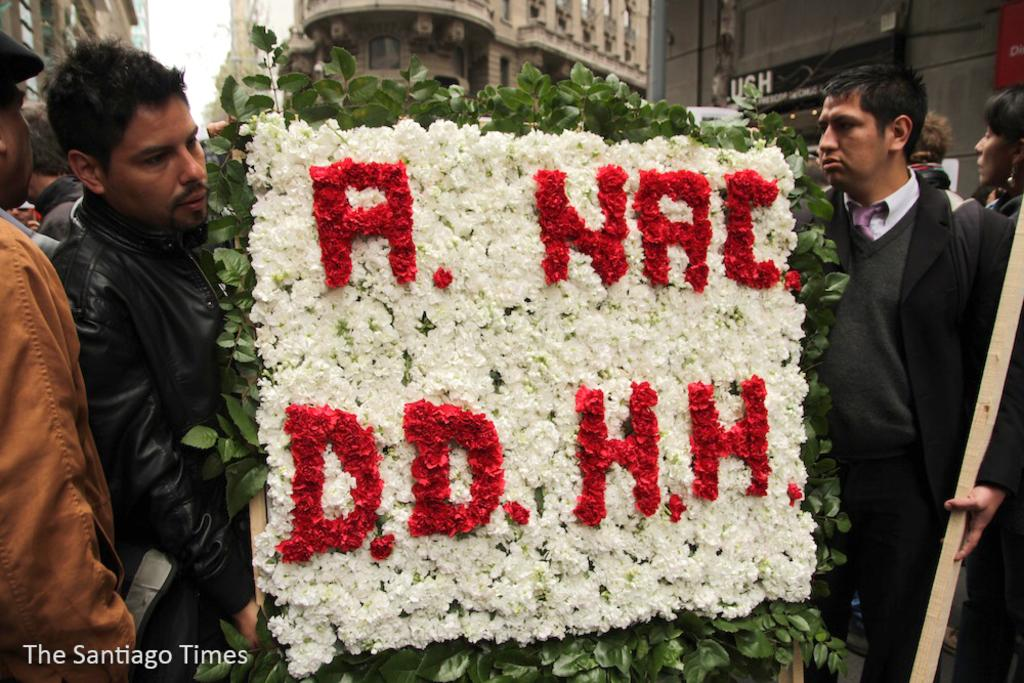What are the men in the image holding? The men in the image are holding a bird. How is the bird decorated? The bird is decorated with flowers and leaves. What can be seen in the background of the image? There are buildings and the sky visible in the background of the image. What type of produce is being sold by the boys in the image? There are no boys or produce present in the image; it features men holding a bird. What is the opinion of the bird in the image? The image does not convey the bird's opinion, as it is an inanimate object. 